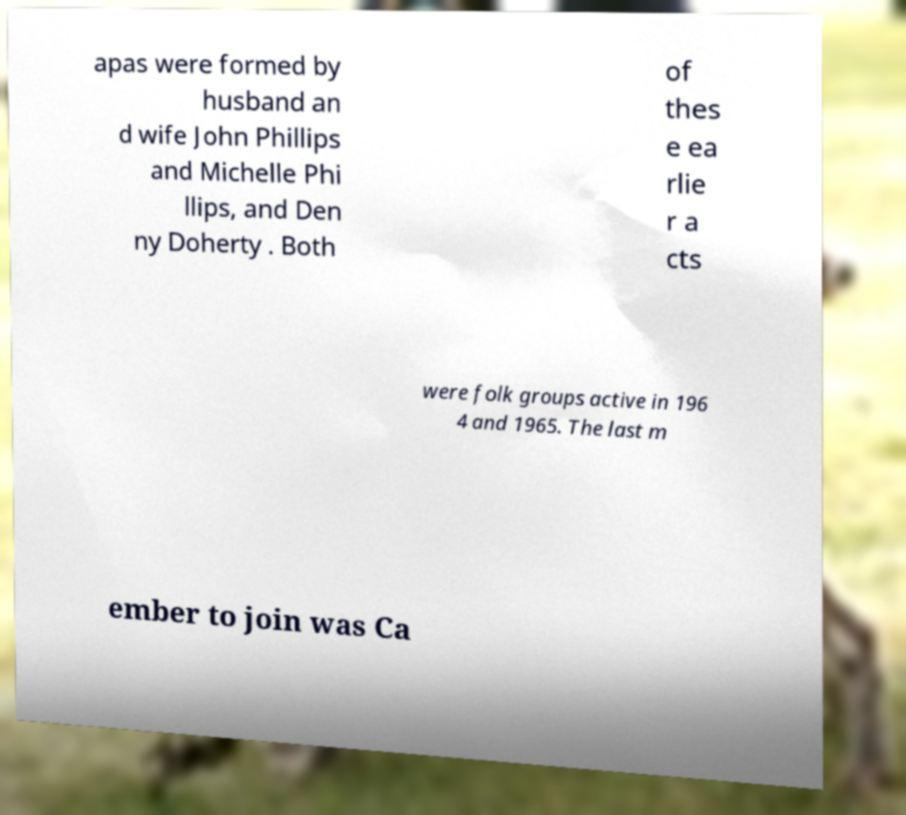Can you read and provide the text displayed in the image?This photo seems to have some interesting text. Can you extract and type it out for me? apas were formed by husband an d wife John Phillips and Michelle Phi llips, and Den ny Doherty . Both of thes e ea rlie r a cts were folk groups active in 196 4 and 1965. The last m ember to join was Ca 